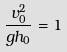<formula> <loc_0><loc_0><loc_500><loc_500>\frac { v _ { 0 } ^ { 2 } } { g h _ { 0 } } = 1</formula> 